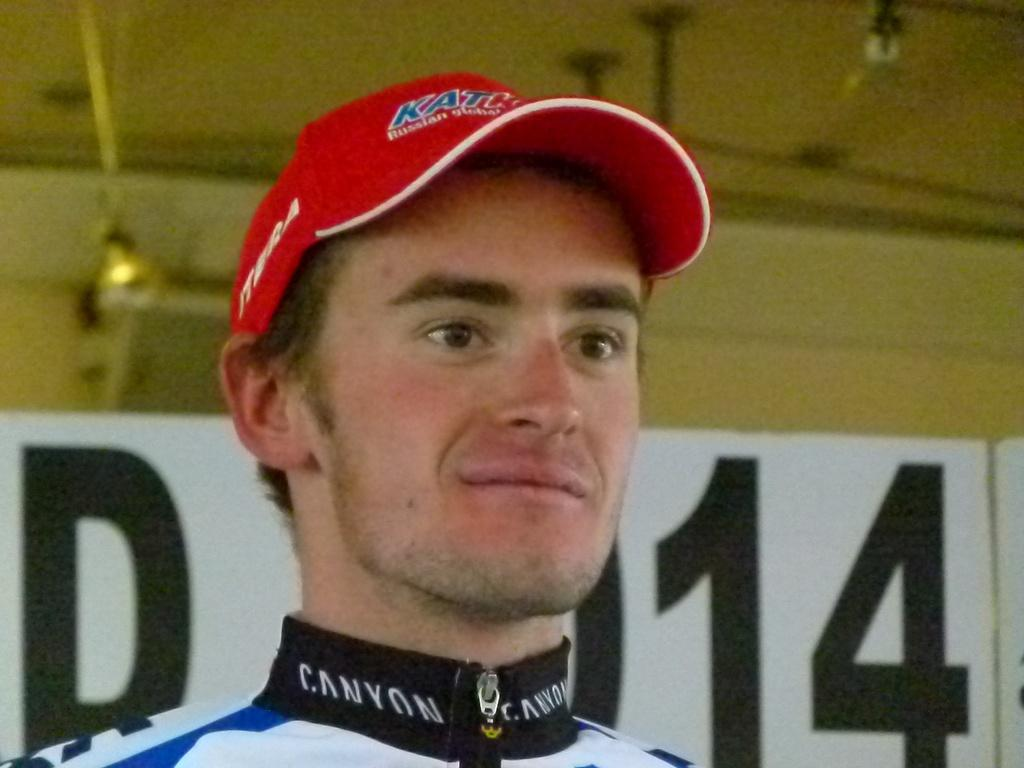What is the person in the image wearing on their head? The person in the image is wearing a cap. What can be seen behind the person in the image? There is a board with letters on it behind the person. What is visible in the background of the image? There is a wall in the background of the image. What can be seen illuminating the scene in the image? There are lights visible in the image. Is the person in the image wearing a crown instead of a cap? No, the person in the image is wearing a cap, not a crown. Is there any indication of death or a funeral in the image? No, there is no indication of death or a funeral in the image. 